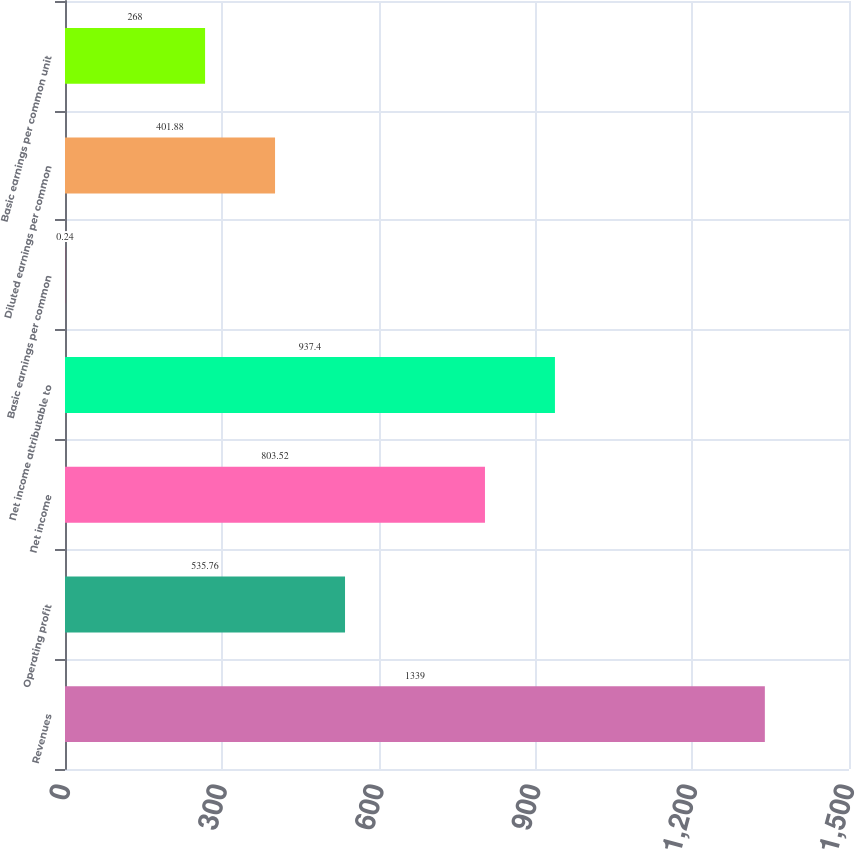<chart> <loc_0><loc_0><loc_500><loc_500><bar_chart><fcel>Revenues<fcel>Operating profit<fcel>Net income<fcel>Net income attributable to<fcel>Basic earnings per common<fcel>Diluted earnings per common<fcel>Basic earnings per common unit<nl><fcel>1339<fcel>535.76<fcel>803.52<fcel>937.4<fcel>0.24<fcel>401.88<fcel>268<nl></chart> 